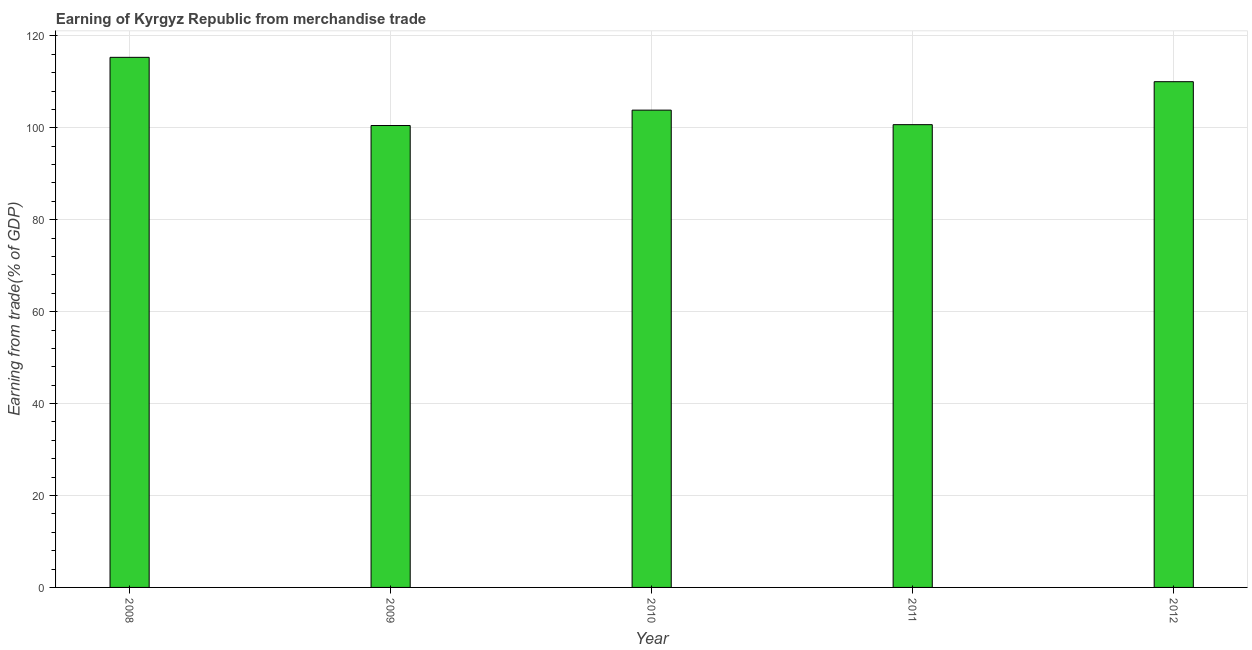What is the title of the graph?
Provide a succinct answer. Earning of Kyrgyz Republic from merchandise trade. What is the label or title of the X-axis?
Offer a very short reply. Year. What is the label or title of the Y-axis?
Provide a short and direct response. Earning from trade(% of GDP). What is the earning from merchandise trade in 2011?
Your answer should be compact. 100.68. Across all years, what is the maximum earning from merchandise trade?
Keep it short and to the point. 115.33. Across all years, what is the minimum earning from merchandise trade?
Keep it short and to the point. 100.49. In which year was the earning from merchandise trade minimum?
Keep it short and to the point. 2009. What is the sum of the earning from merchandise trade?
Keep it short and to the point. 530.38. What is the difference between the earning from merchandise trade in 2010 and 2011?
Provide a short and direct response. 3.16. What is the average earning from merchandise trade per year?
Your answer should be compact. 106.08. What is the median earning from merchandise trade?
Offer a very short reply. 103.84. Do a majority of the years between 2008 and 2012 (inclusive) have earning from merchandise trade greater than 40 %?
Make the answer very short. Yes. What is the ratio of the earning from merchandise trade in 2010 to that in 2012?
Keep it short and to the point. 0.94. Is the earning from merchandise trade in 2010 less than that in 2012?
Provide a short and direct response. Yes. What is the difference between the highest and the second highest earning from merchandise trade?
Your response must be concise. 5.3. Is the sum of the earning from merchandise trade in 2008 and 2012 greater than the maximum earning from merchandise trade across all years?
Offer a terse response. Yes. What is the difference between the highest and the lowest earning from merchandise trade?
Your response must be concise. 14.84. How many bars are there?
Ensure brevity in your answer.  5. How many years are there in the graph?
Make the answer very short. 5. What is the Earning from trade(% of GDP) in 2008?
Your answer should be compact. 115.33. What is the Earning from trade(% of GDP) of 2009?
Keep it short and to the point. 100.49. What is the Earning from trade(% of GDP) in 2010?
Provide a succinct answer. 103.84. What is the Earning from trade(% of GDP) of 2011?
Your answer should be compact. 100.68. What is the Earning from trade(% of GDP) of 2012?
Make the answer very short. 110.03. What is the difference between the Earning from trade(% of GDP) in 2008 and 2009?
Offer a terse response. 14.84. What is the difference between the Earning from trade(% of GDP) in 2008 and 2010?
Make the answer very short. 11.49. What is the difference between the Earning from trade(% of GDP) in 2008 and 2011?
Offer a very short reply. 14.65. What is the difference between the Earning from trade(% of GDP) in 2008 and 2012?
Provide a succinct answer. 5.3. What is the difference between the Earning from trade(% of GDP) in 2009 and 2010?
Provide a short and direct response. -3.35. What is the difference between the Earning from trade(% of GDP) in 2009 and 2011?
Your answer should be very brief. -0.19. What is the difference between the Earning from trade(% of GDP) in 2009 and 2012?
Your answer should be very brief. -9.54. What is the difference between the Earning from trade(% of GDP) in 2010 and 2011?
Your response must be concise. 3.16. What is the difference between the Earning from trade(% of GDP) in 2010 and 2012?
Your answer should be compact. -6.19. What is the difference between the Earning from trade(% of GDP) in 2011 and 2012?
Your answer should be compact. -9.35. What is the ratio of the Earning from trade(% of GDP) in 2008 to that in 2009?
Provide a succinct answer. 1.15. What is the ratio of the Earning from trade(% of GDP) in 2008 to that in 2010?
Keep it short and to the point. 1.11. What is the ratio of the Earning from trade(% of GDP) in 2008 to that in 2011?
Ensure brevity in your answer.  1.15. What is the ratio of the Earning from trade(% of GDP) in 2008 to that in 2012?
Ensure brevity in your answer.  1.05. What is the ratio of the Earning from trade(% of GDP) in 2009 to that in 2011?
Offer a terse response. 1. What is the ratio of the Earning from trade(% of GDP) in 2010 to that in 2011?
Give a very brief answer. 1.03. What is the ratio of the Earning from trade(% of GDP) in 2010 to that in 2012?
Provide a succinct answer. 0.94. What is the ratio of the Earning from trade(% of GDP) in 2011 to that in 2012?
Give a very brief answer. 0.92. 